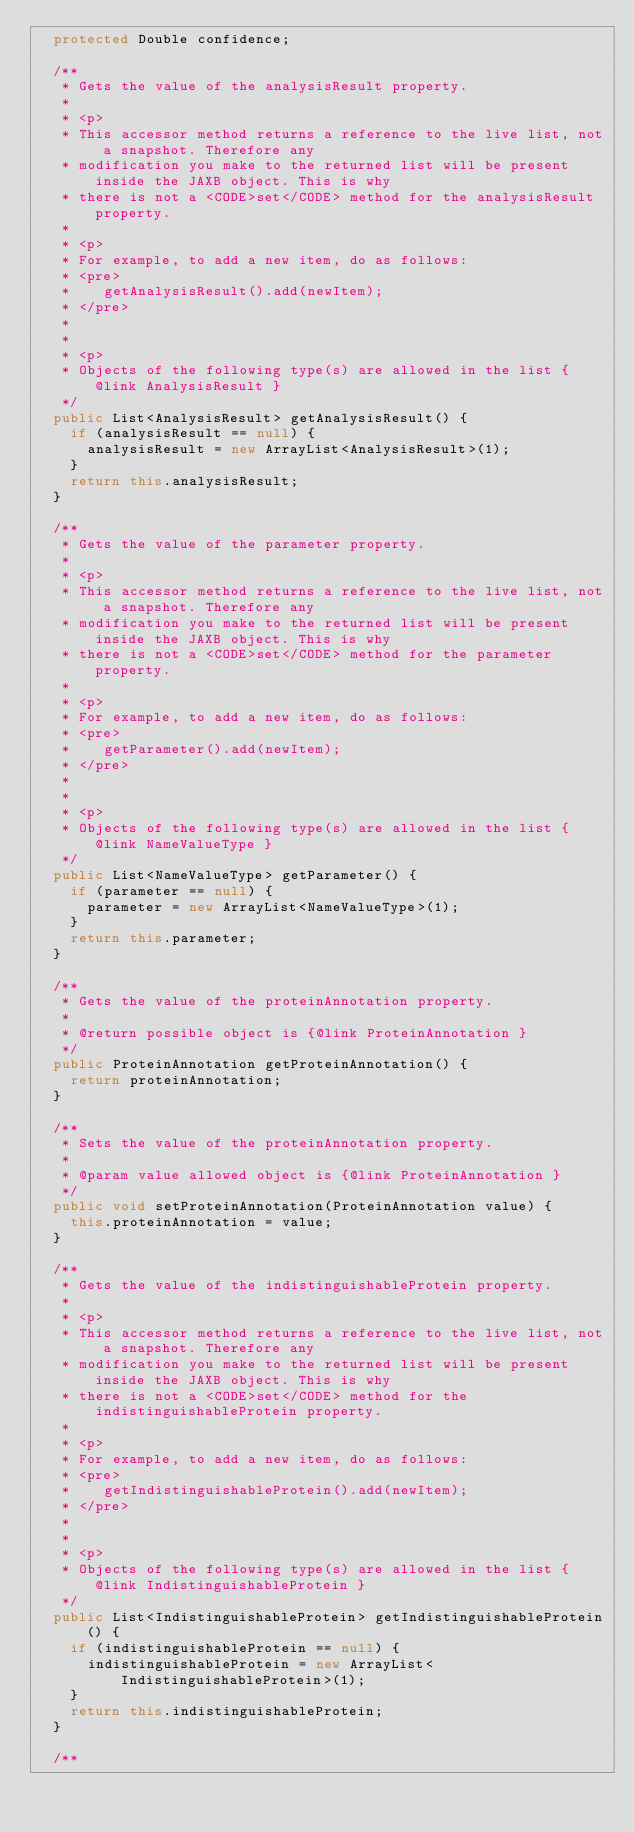<code> <loc_0><loc_0><loc_500><loc_500><_Java_>  protected Double confidence;

  /**
   * Gets the value of the analysisResult property.
   *
   * <p>
   * This accessor method returns a reference to the live list, not a snapshot. Therefore any
   * modification you make to the returned list will be present inside the JAXB object. This is why
   * there is not a <CODE>set</CODE> method for the analysisResult property.
   *
   * <p>
   * For example, to add a new item, do as follows:
   * <pre>
   *    getAnalysisResult().add(newItem);
   * </pre>
   *
   *
   * <p>
   * Objects of the following type(s) are allowed in the list {@link AnalysisResult }
   */
  public List<AnalysisResult> getAnalysisResult() {
    if (analysisResult == null) {
      analysisResult = new ArrayList<AnalysisResult>(1);
    }
    return this.analysisResult;
  }

  /**
   * Gets the value of the parameter property.
   *
   * <p>
   * This accessor method returns a reference to the live list, not a snapshot. Therefore any
   * modification you make to the returned list will be present inside the JAXB object. This is why
   * there is not a <CODE>set</CODE> method for the parameter property.
   *
   * <p>
   * For example, to add a new item, do as follows:
   * <pre>
   *    getParameter().add(newItem);
   * </pre>
   *
   *
   * <p>
   * Objects of the following type(s) are allowed in the list {@link NameValueType }
   */
  public List<NameValueType> getParameter() {
    if (parameter == null) {
      parameter = new ArrayList<NameValueType>(1);
    }
    return this.parameter;
  }

  /**
   * Gets the value of the proteinAnnotation property.
   *
   * @return possible object is {@link ProteinAnnotation }
   */
  public ProteinAnnotation getProteinAnnotation() {
    return proteinAnnotation;
  }

  /**
   * Sets the value of the proteinAnnotation property.
   *
   * @param value allowed object is {@link ProteinAnnotation }
   */
  public void setProteinAnnotation(ProteinAnnotation value) {
    this.proteinAnnotation = value;
  }

  /**
   * Gets the value of the indistinguishableProtein property.
   *
   * <p>
   * This accessor method returns a reference to the live list, not a snapshot. Therefore any
   * modification you make to the returned list will be present inside the JAXB object. This is why
   * there is not a <CODE>set</CODE> method for the indistinguishableProtein property.
   *
   * <p>
   * For example, to add a new item, do as follows:
   * <pre>
   *    getIndistinguishableProtein().add(newItem);
   * </pre>
   *
   *
   * <p>
   * Objects of the following type(s) are allowed in the list {@link IndistinguishableProtein }
   */
  public List<IndistinguishableProtein> getIndistinguishableProtein() {
    if (indistinguishableProtein == null) {
      indistinguishableProtein = new ArrayList<IndistinguishableProtein>(1);
    }
    return this.indistinguishableProtein;
  }

  /**</code> 